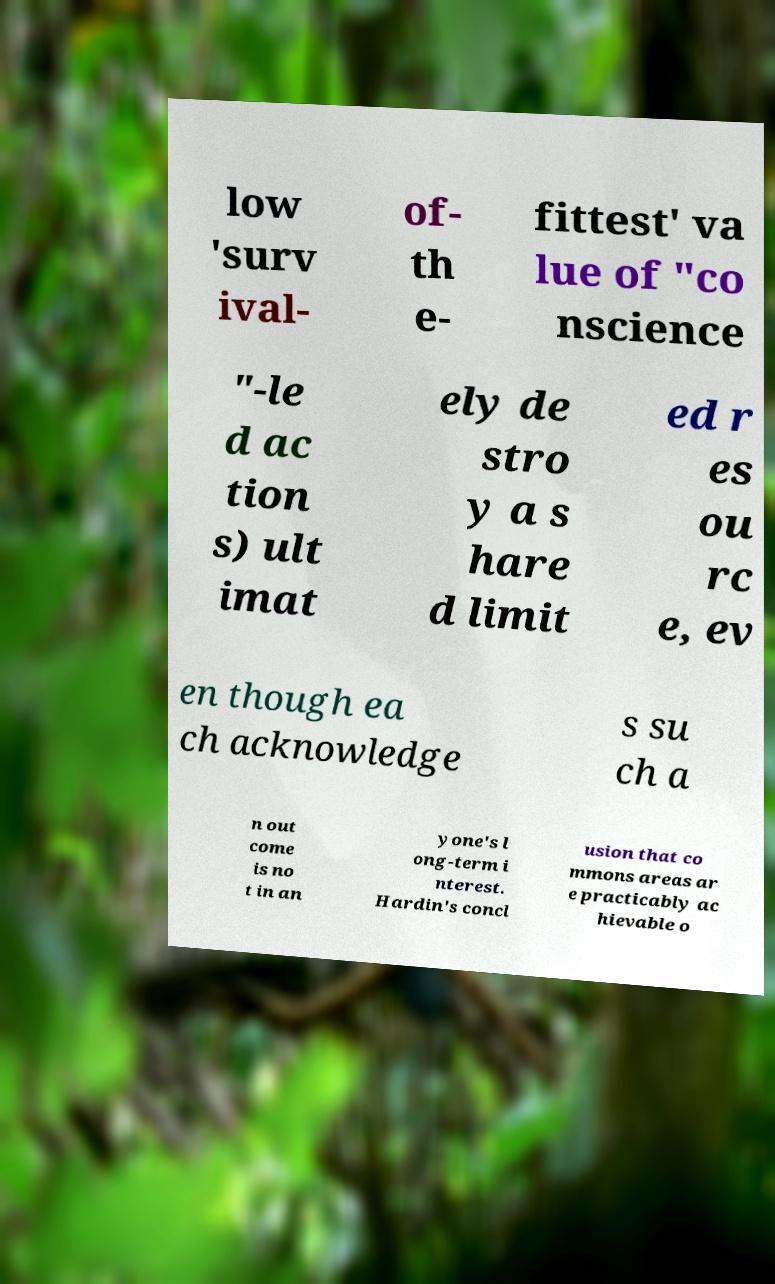Please read and relay the text visible in this image. What does it say? low 'surv ival- of- th e- fittest' va lue of "co nscience "-le d ac tion s) ult imat ely de stro y a s hare d limit ed r es ou rc e, ev en though ea ch acknowledge s su ch a n out come is no t in an yone's l ong-term i nterest. Hardin's concl usion that co mmons areas ar e practicably ac hievable o 